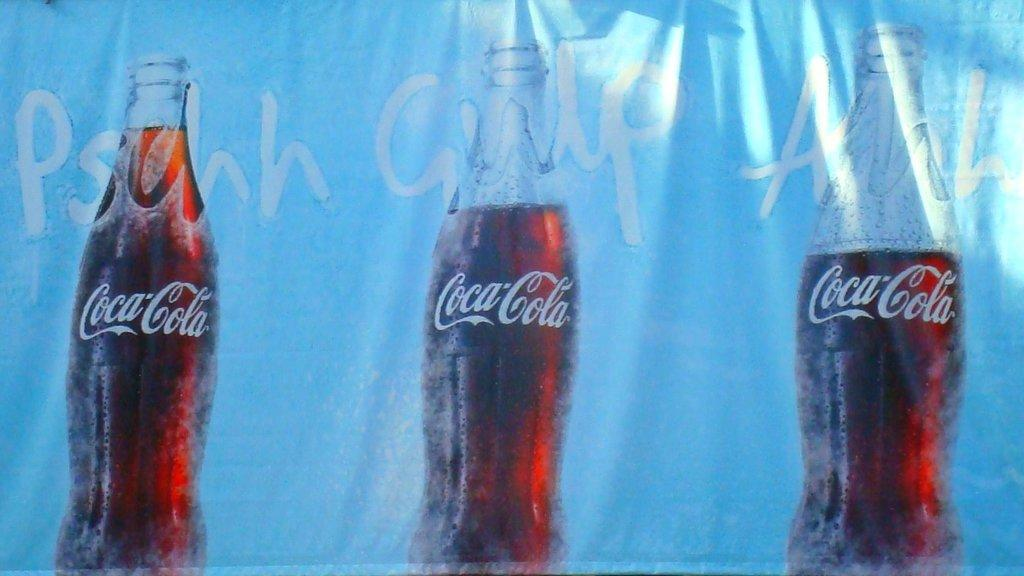What is depicted on the cloth in the image? There are three Coca-Cola bottles printed on the cloth. How many Coca-Cola bottles are shown on the cloth? There are three Coca-Cola bottles depicted on the cloth. What type of food is being prepared on the cloth in the image? There is no food being prepared or depicted on the cloth in the image; it only shows three Coca-Cola bottles. 